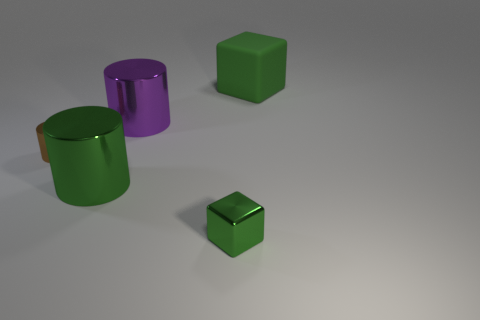There is a cube that is the same size as the purple metallic thing; what is its material?
Offer a very short reply. Rubber. What size is the green block that is behind the tiny cylinder?
Provide a succinct answer. Large. Is the number of large green metallic cylinders that are behind the brown metallic cylinder the same as the number of purple metallic cylinders?
Offer a very short reply. No. Are there any green rubber things that have the same shape as the tiny green metallic thing?
Ensure brevity in your answer.  Yes. There is a thing that is to the left of the green rubber block and behind the brown cylinder; what shape is it?
Provide a short and direct response. Cylinder. Is the material of the brown thing the same as the large green thing that is to the left of the green metal block?
Keep it short and to the point. Yes. Are there any objects left of the green rubber object?
Ensure brevity in your answer.  Yes. How many things are either green rubber objects or big green things that are behind the small cylinder?
Offer a terse response. 1. The metal thing in front of the big green thing to the left of the big purple metal thing is what color?
Offer a very short reply. Green. How many other objects are the same material as the small brown object?
Your answer should be compact. 3. 